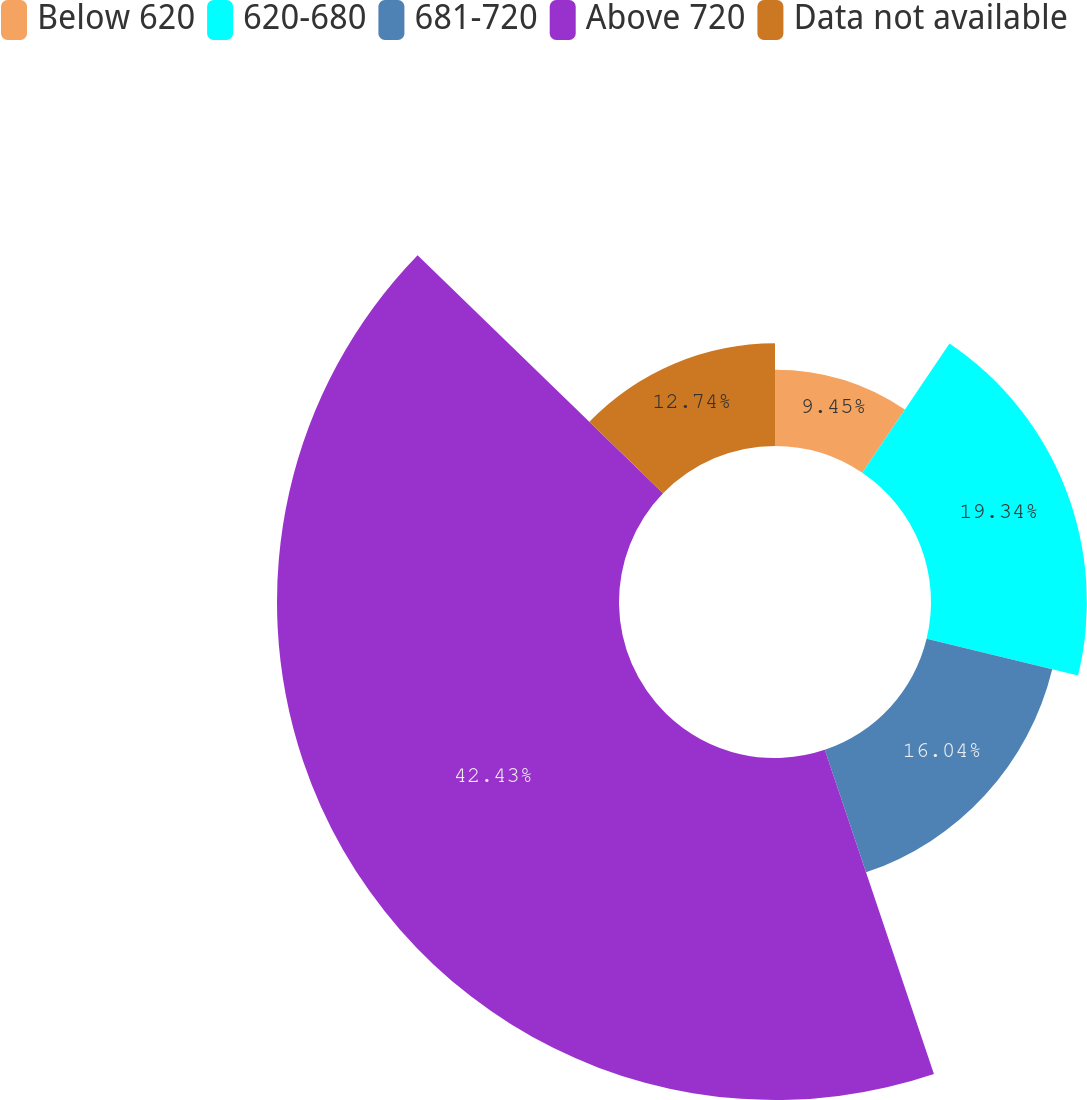Convert chart to OTSL. <chart><loc_0><loc_0><loc_500><loc_500><pie_chart><fcel>Below 620<fcel>620-680<fcel>681-720<fcel>Above 720<fcel>Data not available<nl><fcel>9.45%<fcel>19.34%<fcel>16.04%<fcel>42.43%<fcel>12.74%<nl></chart> 